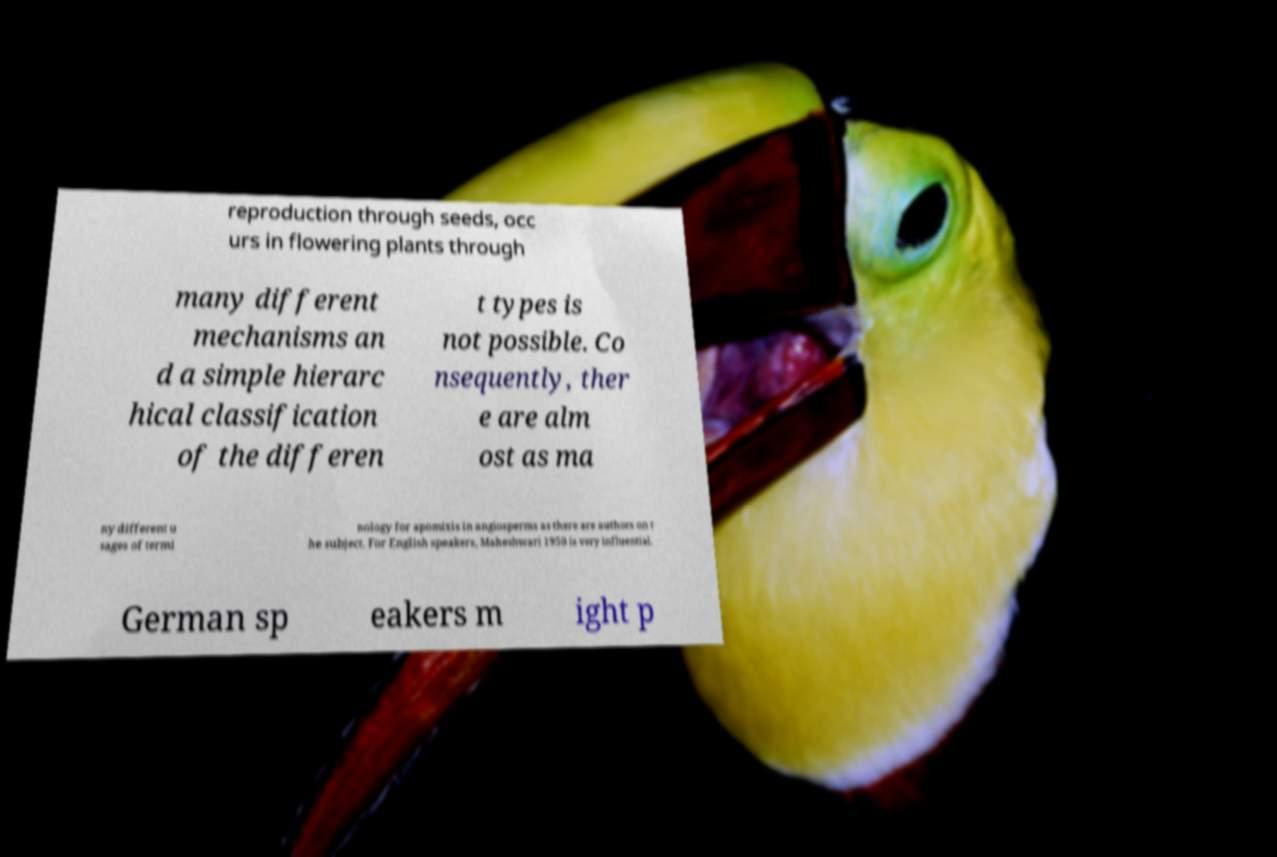For documentation purposes, I need the text within this image transcribed. Could you provide that? reproduction through seeds, occ urs in flowering plants through many different mechanisms an d a simple hierarc hical classification of the differen t types is not possible. Co nsequently, ther e are alm ost as ma ny different u sages of termi nology for apomixis in angiosperms as there are authors on t he subject. For English speakers, Maheshwari 1950 is very influential. German sp eakers m ight p 